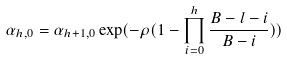<formula> <loc_0><loc_0><loc_500><loc_500>\alpha _ { h , 0 } = \alpha _ { h + 1 , 0 } \exp ( - \rho ( 1 - \prod _ { i = 0 } ^ { h } \frac { B - l - i } { B - i } ) )</formula> 